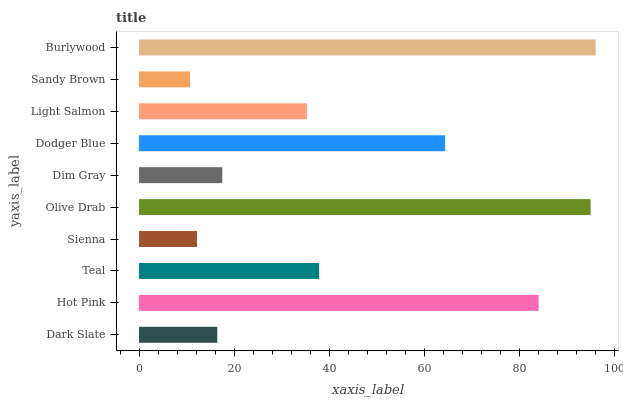Is Sandy Brown the minimum?
Answer yes or no. Yes. Is Burlywood the maximum?
Answer yes or no. Yes. Is Hot Pink the minimum?
Answer yes or no. No. Is Hot Pink the maximum?
Answer yes or no. No. Is Hot Pink greater than Dark Slate?
Answer yes or no. Yes. Is Dark Slate less than Hot Pink?
Answer yes or no. Yes. Is Dark Slate greater than Hot Pink?
Answer yes or no. No. Is Hot Pink less than Dark Slate?
Answer yes or no. No. Is Teal the high median?
Answer yes or no. Yes. Is Light Salmon the low median?
Answer yes or no. Yes. Is Hot Pink the high median?
Answer yes or no. No. Is Dodger Blue the low median?
Answer yes or no. No. 